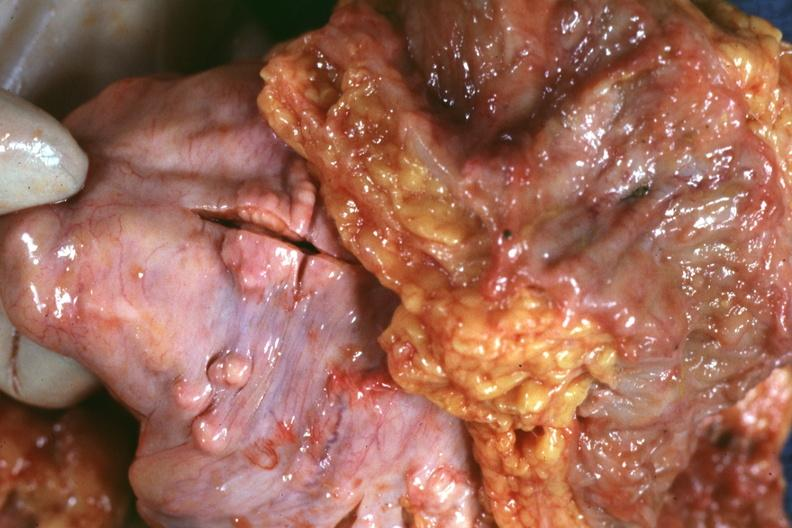where is this area in the body?
Answer the question using a single word or phrase. Abdomen 